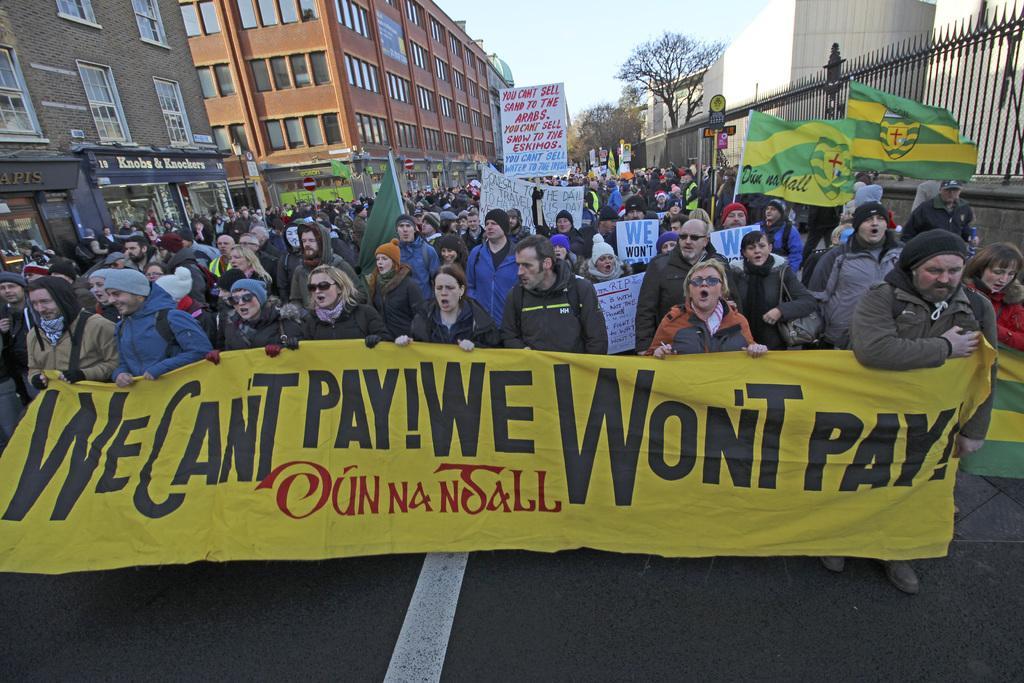Describe this image in one or two sentences. In this image there are people holding the banners, placards. On the right side of the image there is a metal fence. In the background of the image there are buildings, trees, boards, light poles. At the top of the image there is sky. 